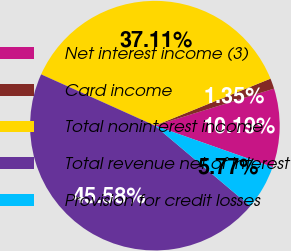Convert chart to OTSL. <chart><loc_0><loc_0><loc_500><loc_500><pie_chart><fcel>Net interest income (3)<fcel>Card income<fcel>Total noninterest income<fcel>Total revenue net of interest<fcel>Provision for credit losses<nl><fcel>10.19%<fcel>1.35%<fcel>37.11%<fcel>45.58%<fcel>5.77%<nl></chart> 